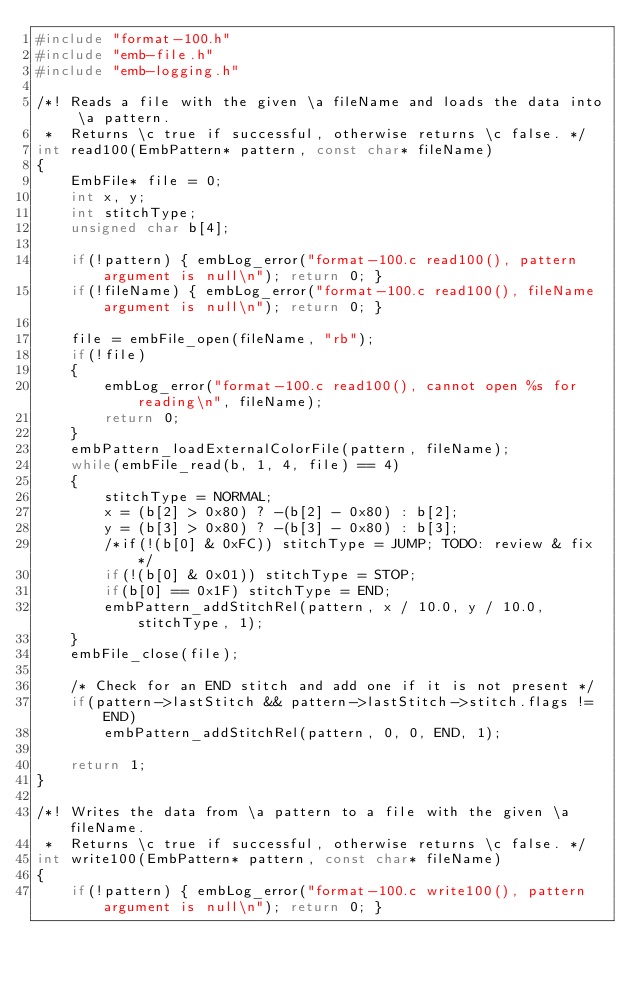Convert code to text. <code><loc_0><loc_0><loc_500><loc_500><_C_>#include "format-100.h"
#include "emb-file.h"
#include "emb-logging.h"

/*! Reads a file with the given \a fileName and loads the data into \a pattern.
 *  Returns \c true if successful, otherwise returns \c false. */
int read100(EmbPattern* pattern, const char* fileName)
{
    EmbFile* file = 0;
    int x, y;
    int stitchType;
    unsigned char b[4];

    if(!pattern) { embLog_error("format-100.c read100(), pattern argument is null\n"); return 0; }
    if(!fileName) { embLog_error("format-100.c read100(), fileName argument is null\n"); return 0; }

    file = embFile_open(fileName, "rb");
    if(!file)
    {
        embLog_error("format-100.c read100(), cannot open %s for reading\n", fileName);
        return 0;
    }
    embPattern_loadExternalColorFile(pattern, fileName);
    while(embFile_read(b, 1, 4, file) == 4)
    {
        stitchType = NORMAL;
        x = (b[2] > 0x80) ? -(b[2] - 0x80) : b[2];
        y = (b[3] > 0x80) ? -(b[3] - 0x80) : b[3];
        /*if(!(b[0] & 0xFC)) stitchType = JUMP; TODO: review & fix */
        if(!(b[0] & 0x01)) stitchType = STOP;
        if(b[0] == 0x1F) stitchType = END;
        embPattern_addStitchRel(pattern, x / 10.0, y / 10.0, stitchType, 1);
    }
    embFile_close(file);

    /* Check for an END stitch and add one if it is not present */
    if(pattern->lastStitch && pattern->lastStitch->stitch.flags != END)
        embPattern_addStitchRel(pattern, 0, 0, END, 1);

    return 1;
}

/*! Writes the data from \a pattern to a file with the given \a fileName.
 *  Returns \c true if successful, otherwise returns \c false. */
int write100(EmbPattern* pattern, const char* fileName)
{
    if(!pattern) { embLog_error("format-100.c write100(), pattern argument is null\n"); return 0; }</code> 